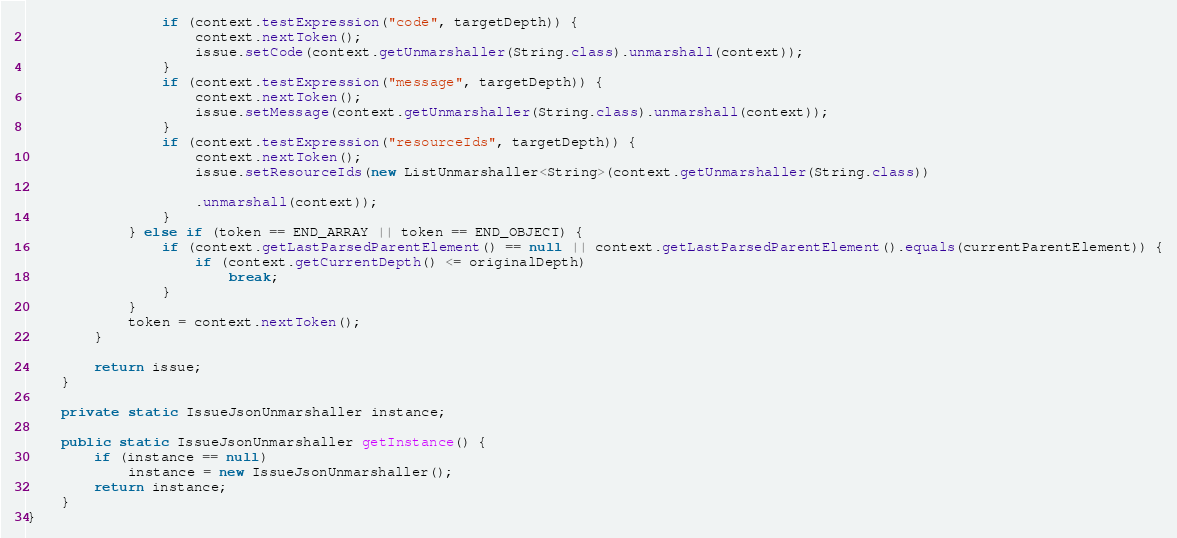<code> <loc_0><loc_0><loc_500><loc_500><_Java_>                if (context.testExpression("code", targetDepth)) {
                    context.nextToken();
                    issue.setCode(context.getUnmarshaller(String.class).unmarshall(context));
                }
                if (context.testExpression("message", targetDepth)) {
                    context.nextToken();
                    issue.setMessage(context.getUnmarshaller(String.class).unmarshall(context));
                }
                if (context.testExpression("resourceIds", targetDepth)) {
                    context.nextToken();
                    issue.setResourceIds(new ListUnmarshaller<String>(context.getUnmarshaller(String.class))

                    .unmarshall(context));
                }
            } else if (token == END_ARRAY || token == END_OBJECT) {
                if (context.getLastParsedParentElement() == null || context.getLastParsedParentElement().equals(currentParentElement)) {
                    if (context.getCurrentDepth() <= originalDepth)
                        break;
                }
            }
            token = context.nextToken();
        }

        return issue;
    }

    private static IssueJsonUnmarshaller instance;

    public static IssueJsonUnmarshaller getInstance() {
        if (instance == null)
            instance = new IssueJsonUnmarshaller();
        return instance;
    }
}
</code> 